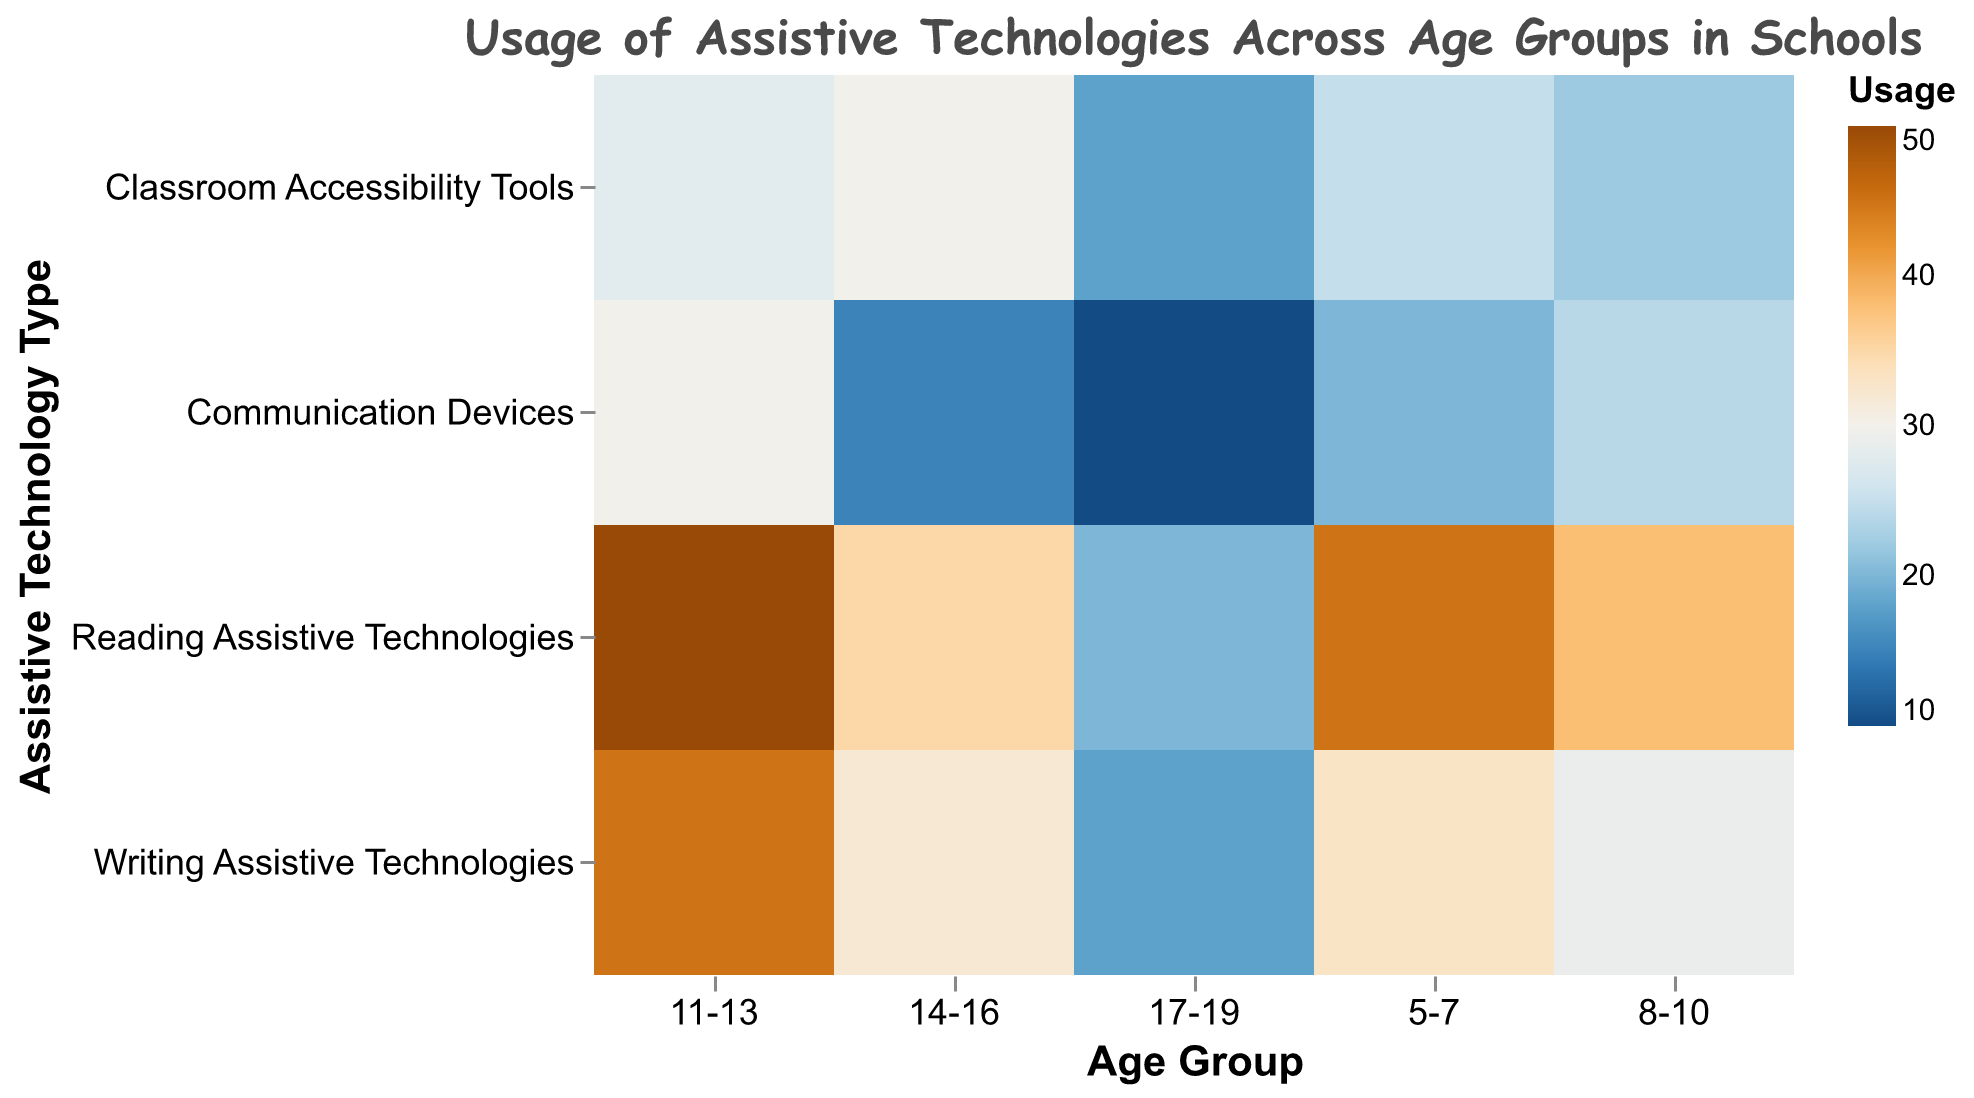What is the title of the figure? The title of the heatmap is usually positioned at the top and is visually distinct due to its size and font style.
Answer: Usage of Assistive Technologies Across Age Groups in Schools Which two assistive technologies have the highest usage for the '11-13' age group? Locate the row corresponding to the '11-13' age group and find the two cells with the highest usage values within that row. The values are 50 (Reading Assistive Technologies) and 45 (Writing Assistive Technologies).
Answer: Reading Assistive Technologies and Writing Assistive Technologies What age group has the lowest usage of Communication Devices? Check the column for Communication Devices and find the cell with the smallest value. The smallest value is 10, corresponding to the '17-19' age group.
Answer: 17-19 What is the total usage of Classroom Accessibility Tools across all age groups? Sum up the values in the Classroom Accessibility Tools column: 25 (5-7) + 22 (8-10) + 28 (11-13) + 30 (14-16) + 18 (17-19). This equals 123.
Answer: 123 Which age group uses Reading Assistive Technologies the most? Examine the Reading Assistive Technologies column and identify the highest value. The highest value is 50 for the '11-13' age group.
Answer: 11-13 What is the average usage of Writing Assistive Technologies across all age groups? Calculate the sum of the values in the Writing Assistive Technologies column: 33 + 29 + 45 + 32 + 18 = 157. Then, divide by the number of age groups (5): 157/5 = 31.4.
Answer: 31.4 Is the usage of Classroom Accessibility Tools higher for the '14-16' age group or the '8-10' age group? Compare the values for the '14-16' and '8-10' age groups in the Classroom Accessibility Tools column. The values are 30 and 22, respectively. 30 is greater than 22, indicating higher usage for the '14-16' age group.
Answer: 14-16 By how much does the usage of Reading Assistive Technologies decrease from the '11-13' age group to the '17-19' age group? Subtract the usage value of Reading Assistive Technologies for the '17-19' age group (20) from that of the '11-13' age group (50): 50 - 20 = 30.
Answer: 30 What is the overall trend in the usage of Communication Devices across the age groups? Observe the values in the Communication Devices column from youngest to oldest age groups: 20 (5-7), 24 (8-10), 30 (11-13), 15 (14-16), 10 (17-19). The usage generally peaks at 11-13 and then declines towards 17-19.
Answer: Peaks at 11-13, then declines 